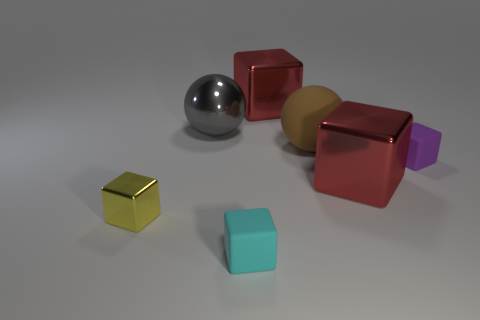How many spheres are either large things or tiny purple rubber objects?
Keep it short and to the point. 2. Is the material of the small thing that is to the right of the cyan thing the same as the large ball behind the large matte object?
Keep it short and to the point. No. What is the shape of the gray thing that is the same size as the matte sphere?
Provide a succinct answer. Sphere. What number of other objects are there of the same color as the large matte sphere?
Your answer should be compact. 0. What number of yellow objects are either metallic balls or tiny shiny objects?
Your response must be concise. 1. There is a rubber thing to the right of the brown rubber object; is it the same shape as the red metallic thing behind the gray ball?
Provide a short and direct response. Yes. How many other things are made of the same material as the gray ball?
Give a very brief answer. 3. There is a large red shiny block that is behind the tiny rubber object that is behind the yellow metal cube; is there a small cyan cube to the left of it?
Provide a succinct answer. Yes. Are the small cyan block and the gray sphere made of the same material?
Your answer should be very brief. No. Is there anything else that is the same shape as the brown rubber object?
Keep it short and to the point. Yes. 